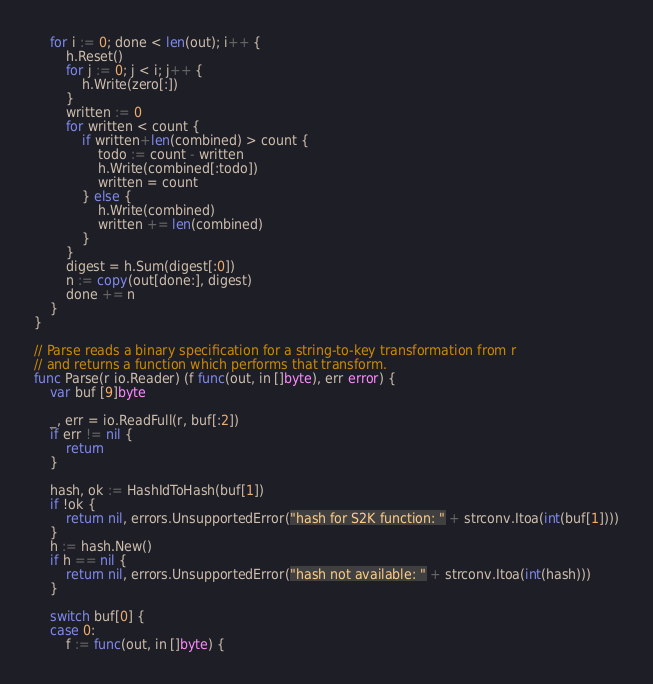<code> <loc_0><loc_0><loc_500><loc_500><_Go_>	for i := 0; done < len(out); i++ {
		h.Reset()
		for j := 0; j < i; j++ {
			h.Write(zero[:])
		}
		written := 0
		for written < count {
			if written+len(combined) > count {
				todo := count - written
				h.Write(combined[:todo])
				written = count
			} else {
				h.Write(combined)
				written += len(combined)
			}
		}
		digest = h.Sum(digest[:0])
		n := copy(out[done:], digest)
		done += n
	}
}

// Parse reads a binary specification for a string-to-key transformation from r
// and returns a function which performs that transform.
func Parse(r io.Reader) (f func(out, in []byte), err error) {
	var buf [9]byte

	_, err = io.ReadFull(r, buf[:2])
	if err != nil {
		return
	}

	hash, ok := HashIdToHash(buf[1])
	if !ok {
		return nil, errors.UnsupportedError("hash for S2K function: " + strconv.Itoa(int(buf[1])))
	}
	h := hash.New()
	if h == nil {
		return nil, errors.UnsupportedError("hash not available: " + strconv.Itoa(int(hash)))
	}

	switch buf[0] {
	case 0:
		f := func(out, in []byte) {</code> 